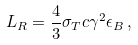Convert formula to latex. <formula><loc_0><loc_0><loc_500><loc_500>L _ { R } = \frac { 4 } { 3 } \sigma _ { T } c \gamma ^ { 2 } \epsilon _ { B } \, ,</formula> 